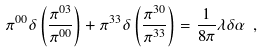Convert formula to latex. <formula><loc_0><loc_0><loc_500><loc_500>\pi ^ { 0 0 } \delta \left ( \frac { \pi ^ { 0 3 } } { \pi ^ { 0 0 } } \right ) + \pi ^ { 3 3 } \delta \left ( \frac { \pi ^ { 3 0 } } { \pi ^ { 3 3 } } \right ) = \frac { 1 } { 8 \pi } \lambda \delta \alpha \ ,</formula> 